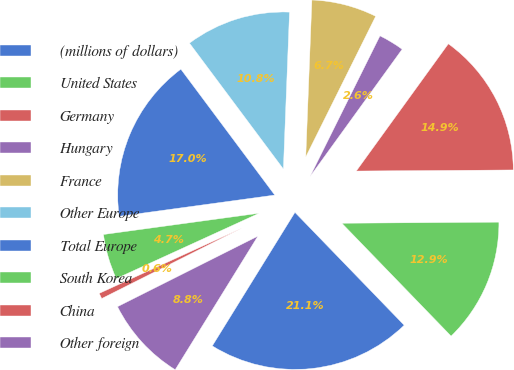<chart> <loc_0><loc_0><loc_500><loc_500><pie_chart><fcel>(millions of dollars)<fcel>United States<fcel>Germany<fcel>Hungary<fcel>France<fcel>Other Europe<fcel>Total Europe<fcel>South Korea<fcel>China<fcel>Other foreign<nl><fcel>21.06%<fcel>12.87%<fcel>14.92%<fcel>2.63%<fcel>6.72%<fcel>10.82%<fcel>16.96%<fcel>4.67%<fcel>0.58%<fcel>8.77%<nl></chart> 